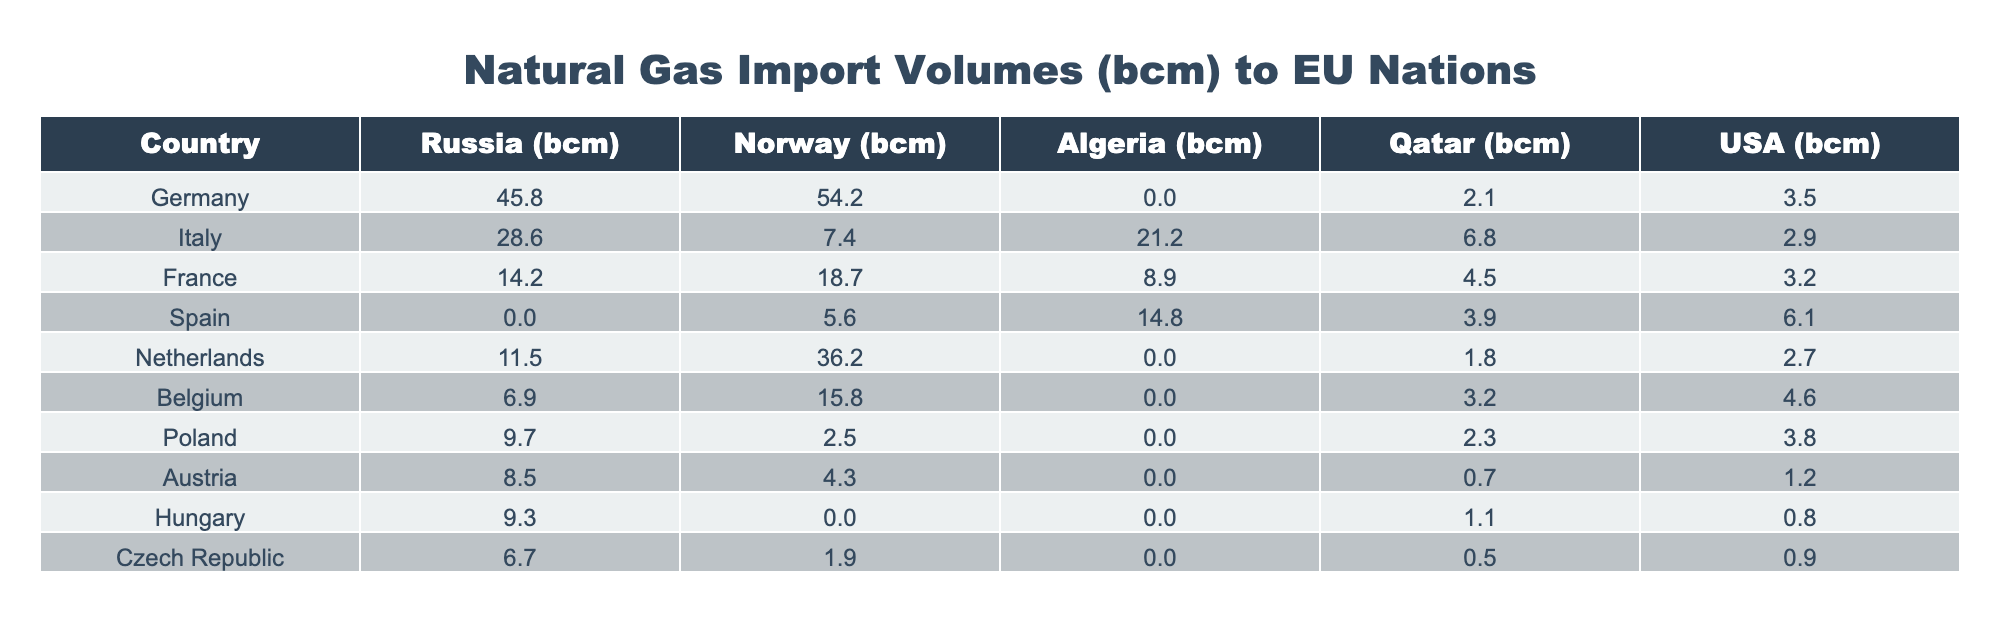What is the total amount of natural gas imported by Germany from Norway? From the table, Germany imports 54.2 bcm of natural gas from Norway.
Answer: 54.2 bcm Which country imported the least natural gas from the USA? The table shows that Hungary imported 0.8 bcm from the USA, which is the least among all the countries listed.
Answer: Hungary What is the difference in natural gas imports from Qatar between Germany and Italy? Germany imported 2.1 bcm from Qatar, while Italy imported 6.8 bcm. The difference is 6.8 - 2.1 = 4.7 bcm.
Answer: 4.7 bcm Which country has the highest total natural gas import volume? To determine this, add the volumes for each country. Germany has 45.8 + 54.2 + 0 + 2.1 + 3.5 = 105.6 bcm, the highest compared to others.
Answer: Germany Did Spain import any natural gas from Russia? According to the table, Spain has 0 bcm imported from Russia, confirming that they did not import any.
Answer: No What is the average natural gas import volume from Norway across all countries listed? Adding the Norway imports: 54.2 + 7.4 + 18.7 + 5.6 + 36.2 + 15.8 + 2.5 + 4.3 + 0 + 0 + 1.9 = 143.6 bcm. There are 11 countries, so the average is 143.6 / 11 = 13.1 bcm.
Answer: 13.1 bcm Which country has a higher import volume from Algeria, Italy or France? Italy imported 21.2 bcm while France imported 8.9 bcm from Algeria. Since 21.2 > 8.9, Italy has the higher volume.
Answer: Italy How much more natural gas did Belgium import from Norway compared to the USA? Belgium imported 15.8 bcm from Norway and 4.6 bcm from the USA. The difference is 15.8 - 4.6 = 11.2 bcm more from Norway.
Answer: 11.2 bcm Which country had no imports from Algeria? By examining the table, it is clear that Germany, Spain, and Hungary have 0 bcm imported from Algeria.
Answer: Germany, Spain, Hungary 